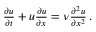Convert formula to latex. <formula><loc_0><loc_0><loc_500><loc_500>\begin{array} { r } { \frac { \partial u } { \partial t } + u \frac { \partial u } { \partial x } = \nu \frac { \partial ^ { 2 } u } { \partial x ^ { 2 } } \, . } \end{array}</formula> 